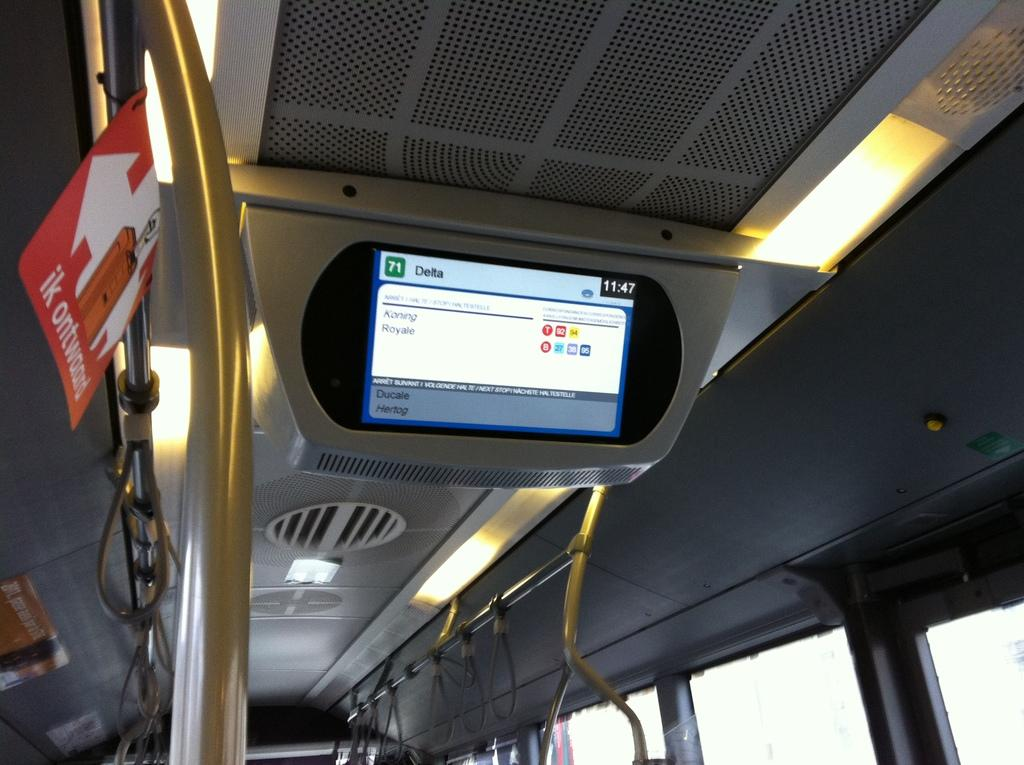What type of space is depicted in the image? The image shows the interior of a vehicle. What feature allows passengers to see outside the vehicle? There are windows in the vehicle. What device is present for entertainment or information purposes? There is a screen present in the vehicle. What can be used to illuminate the interior of the vehicle? There are lights visible in the image. What surface might be used for displaying information or advertisements? There is a board in the vehicle. What feature is designed to provide support for standing passengers? Bus handles are attached to poles in the vehicle. How many oranges are being held by the foot in the image? There are no oranges or feet visible in the image; it shows the interior of a vehicle. 